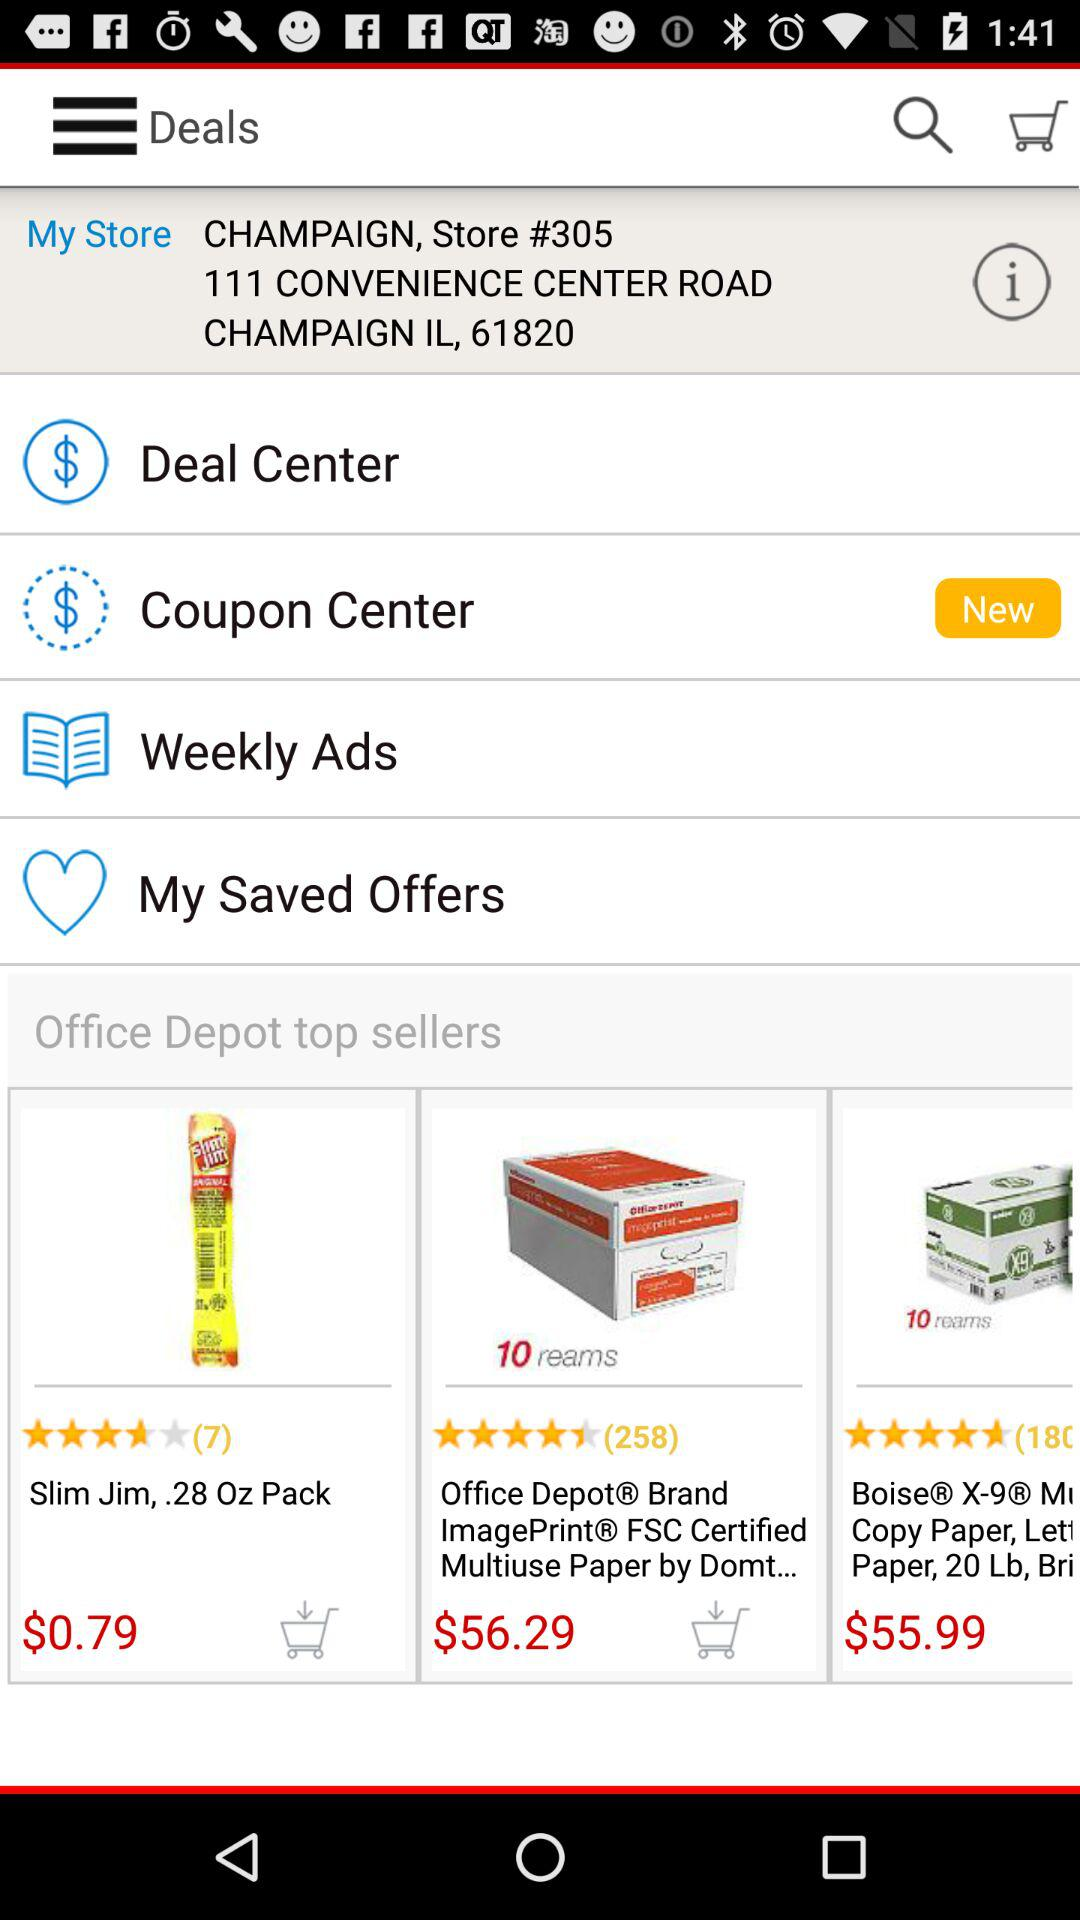Who are the top sellers of Office Depot? The top sellers of Office Depot are "Slim Jim,.28 Oz Pack" and "Office Depot® Brand ImagePrint® FSC Certified Multiuse Paper by Domt...". 